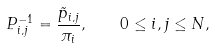Convert formula to latex. <formula><loc_0><loc_0><loc_500><loc_500>P _ { i , j } ^ { - 1 } = \frac { \tilde { p } _ { i , j } } { \pi _ { i } } , \quad 0 \leq i , j \leq N ,</formula> 